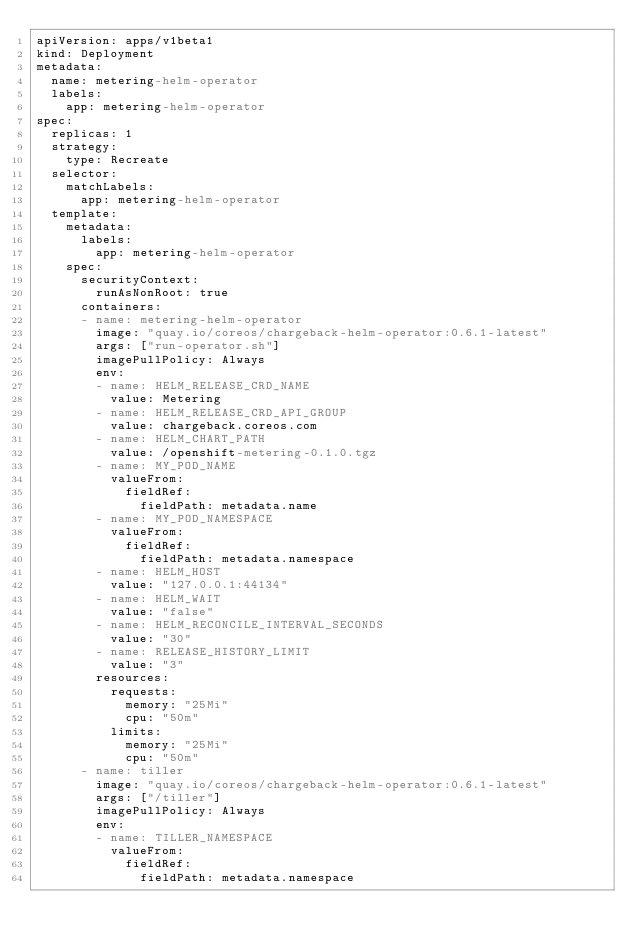Convert code to text. <code><loc_0><loc_0><loc_500><loc_500><_YAML_>apiVersion: apps/v1beta1
kind: Deployment
metadata:
  name: metering-helm-operator
  labels:
    app: metering-helm-operator
spec:
  replicas: 1
  strategy:
    type: Recreate
  selector:
    matchLabels:
      app: metering-helm-operator
  template:
    metadata:
      labels:
        app: metering-helm-operator
    spec:
      securityContext:
        runAsNonRoot: true
      containers:
      - name: metering-helm-operator
        image: "quay.io/coreos/chargeback-helm-operator:0.6.1-latest"
        args: ["run-operator.sh"]
        imagePullPolicy: Always
        env:
        - name: HELM_RELEASE_CRD_NAME
          value: Metering
        - name: HELM_RELEASE_CRD_API_GROUP
          value: chargeback.coreos.com
        - name: HELM_CHART_PATH
          value: /openshift-metering-0.1.0.tgz
        - name: MY_POD_NAME
          valueFrom:
            fieldRef:
              fieldPath: metadata.name
        - name: MY_POD_NAMESPACE
          valueFrom:
            fieldRef:
              fieldPath: metadata.namespace
        - name: HELM_HOST
          value: "127.0.0.1:44134"
        - name: HELM_WAIT
          value: "false"
        - name: HELM_RECONCILE_INTERVAL_SECONDS
          value: "30"
        - name: RELEASE_HISTORY_LIMIT
          value: "3"
        resources:
          requests:
            memory: "25Mi"
            cpu: "50m"
          limits:
            memory: "25Mi"
            cpu: "50m"
      - name: tiller
        image: "quay.io/coreos/chargeback-helm-operator:0.6.1-latest"
        args: ["/tiller"]
        imagePullPolicy: Always
        env:
        - name: TILLER_NAMESPACE
          valueFrom:
            fieldRef:
              fieldPath: metadata.namespace</code> 